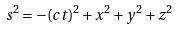Convert formula to latex. <formula><loc_0><loc_0><loc_500><loc_500>s ^ { 2 } = - ( c t ) ^ { 2 } + x ^ { 2 } + y ^ { 2 } + z ^ { 2 }</formula> 